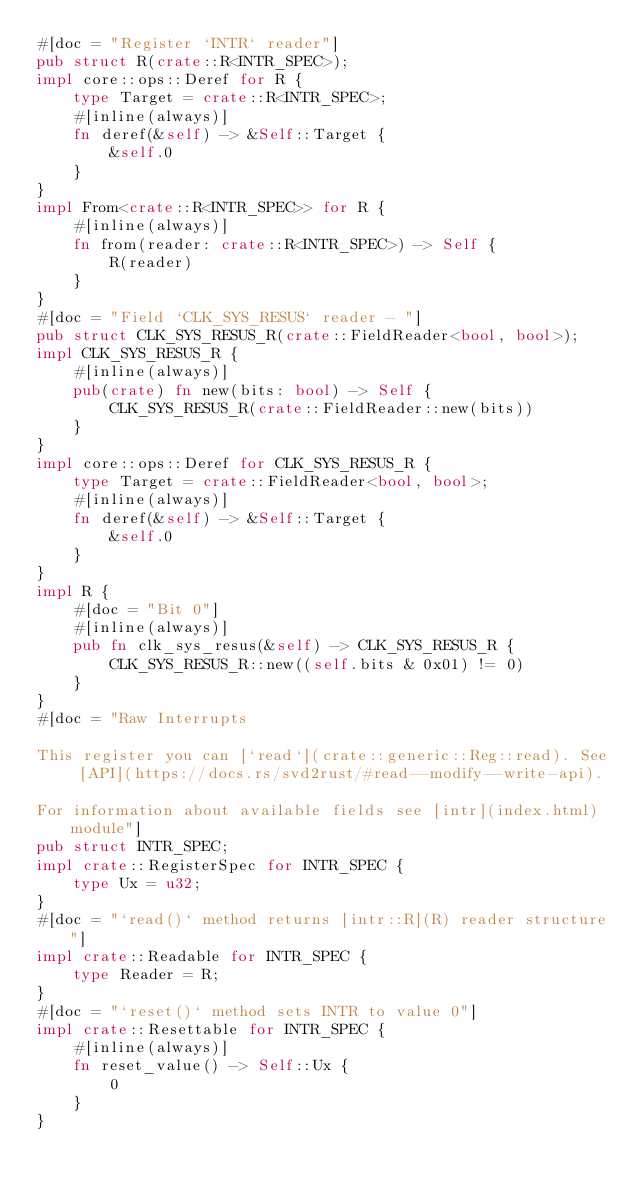Convert code to text. <code><loc_0><loc_0><loc_500><loc_500><_Rust_>#[doc = "Register `INTR` reader"]
pub struct R(crate::R<INTR_SPEC>);
impl core::ops::Deref for R {
    type Target = crate::R<INTR_SPEC>;
    #[inline(always)]
    fn deref(&self) -> &Self::Target {
        &self.0
    }
}
impl From<crate::R<INTR_SPEC>> for R {
    #[inline(always)]
    fn from(reader: crate::R<INTR_SPEC>) -> Self {
        R(reader)
    }
}
#[doc = "Field `CLK_SYS_RESUS` reader - "]
pub struct CLK_SYS_RESUS_R(crate::FieldReader<bool, bool>);
impl CLK_SYS_RESUS_R {
    #[inline(always)]
    pub(crate) fn new(bits: bool) -> Self {
        CLK_SYS_RESUS_R(crate::FieldReader::new(bits))
    }
}
impl core::ops::Deref for CLK_SYS_RESUS_R {
    type Target = crate::FieldReader<bool, bool>;
    #[inline(always)]
    fn deref(&self) -> &Self::Target {
        &self.0
    }
}
impl R {
    #[doc = "Bit 0"]
    #[inline(always)]
    pub fn clk_sys_resus(&self) -> CLK_SYS_RESUS_R {
        CLK_SYS_RESUS_R::new((self.bits & 0x01) != 0)
    }
}
#[doc = "Raw Interrupts  

This register you can [`read`](crate::generic::Reg::read). See [API](https://docs.rs/svd2rust/#read--modify--write-api).  

For information about available fields see [intr](index.html) module"]
pub struct INTR_SPEC;
impl crate::RegisterSpec for INTR_SPEC {
    type Ux = u32;
}
#[doc = "`read()` method returns [intr::R](R) reader structure"]
impl crate::Readable for INTR_SPEC {
    type Reader = R;
}
#[doc = "`reset()` method sets INTR to value 0"]
impl crate::Resettable for INTR_SPEC {
    #[inline(always)]
    fn reset_value() -> Self::Ux {
        0
    }
}
</code> 